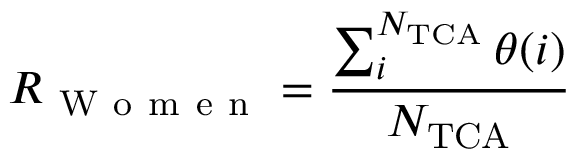Convert formula to latex. <formula><loc_0><loc_0><loc_500><loc_500>R _ { W o m e n } = \frac { \sum _ { i } ^ { N _ { T C A } } \theta ( i ) } { N _ { T C A } }</formula> 